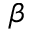Convert formula to latex. <formula><loc_0><loc_0><loc_500><loc_500>\beta</formula> 